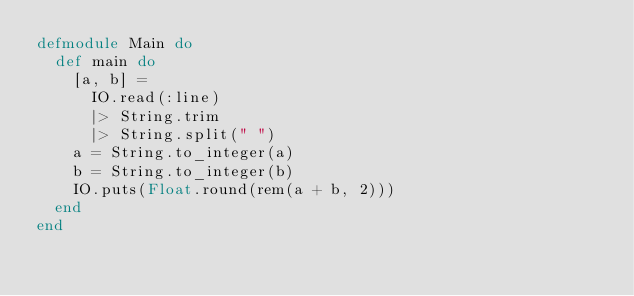Convert code to text. <code><loc_0><loc_0><loc_500><loc_500><_Elixir_>defmodule Main do
  def main do
    [a, b] =
      IO.read(:line)
      |> String.trim
      |> String.split(" ")
    a = String.to_integer(a)
    b = String.to_integer(b)
    IO.puts(Float.round(rem(a + b, 2)))
  end
end
</code> 